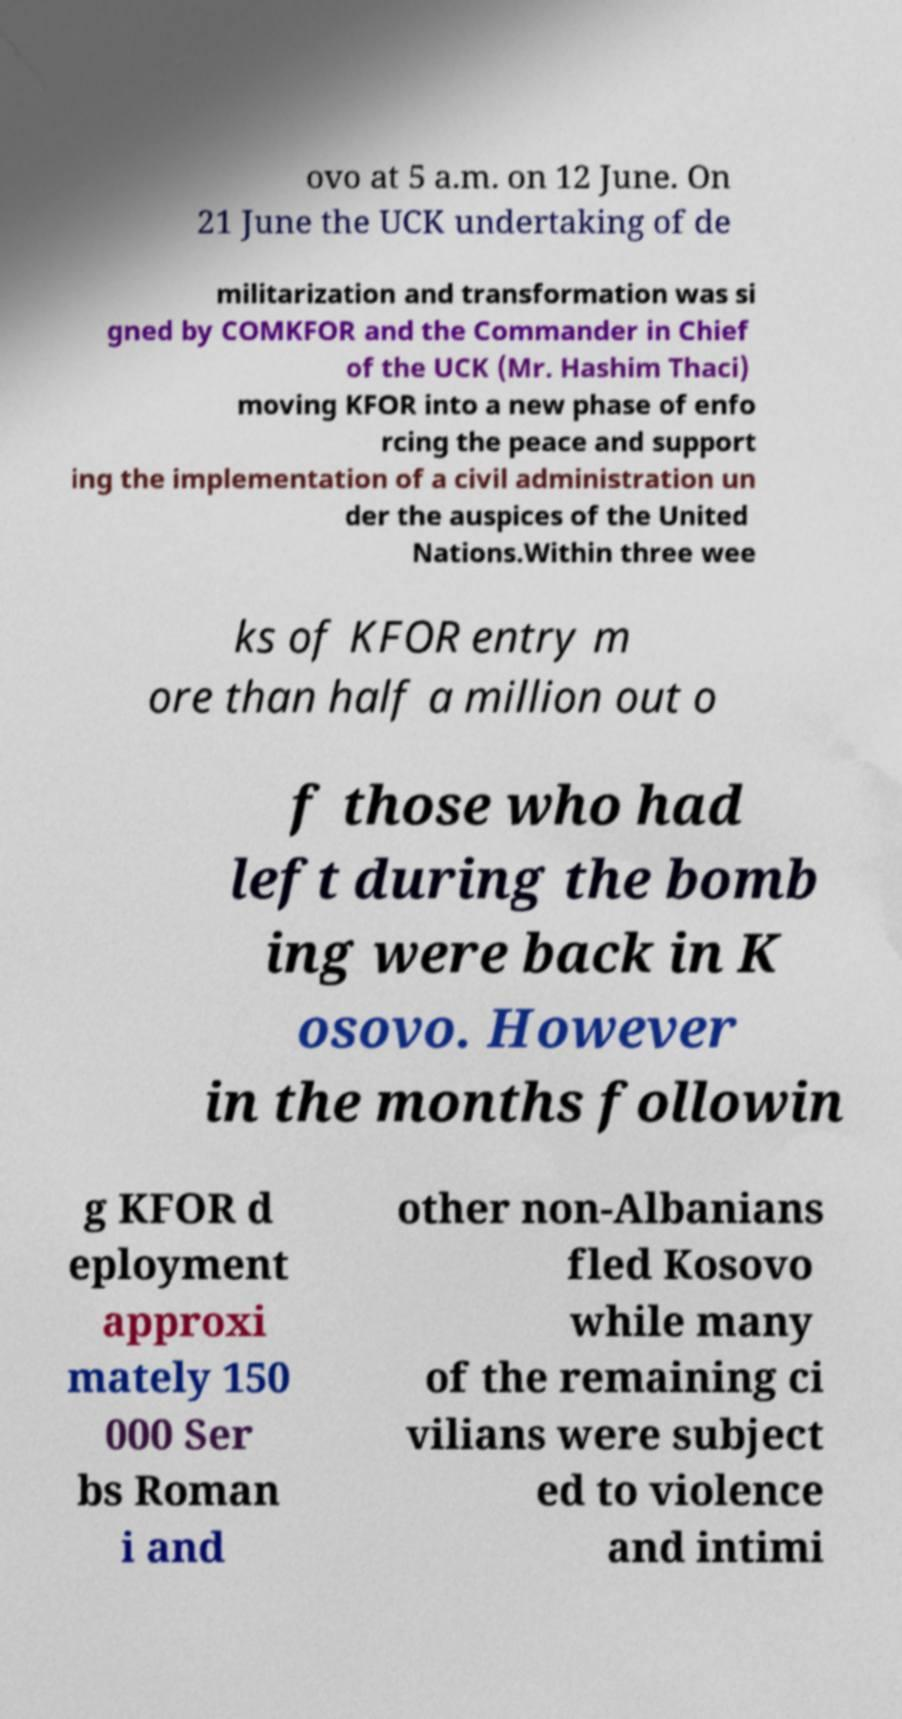For documentation purposes, I need the text within this image transcribed. Could you provide that? ovo at 5 a.m. on 12 June. On 21 June the UCK undertaking of de militarization and transformation was si gned by COMKFOR and the Commander in Chief of the UCK (Mr. Hashim Thaci) moving KFOR into a new phase of enfo rcing the peace and support ing the implementation of a civil administration un der the auspices of the United Nations.Within three wee ks of KFOR entry m ore than half a million out o f those who had left during the bomb ing were back in K osovo. However in the months followin g KFOR d eployment approxi mately 150 000 Ser bs Roman i and other non-Albanians fled Kosovo while many of the remaining ci vilians were subject ed to violence and intimi 